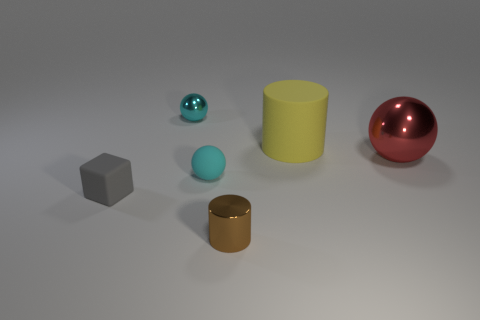Is there a brown object of the same shape as the cyan rubber object?
Offer a terse response. No. What is the shape of the other matte thing that is the same size as the gray object?
Offer a very short reply. Sphere. Is the color of the small metallic ball the same as the rubber thing to the right of the tiny brown cylinder?
Make the answer very short. No. There is a matte object on the right side of the brown shiny thing; what number of small gray blocks are behind it?
Make the answer very short. 0. There is a sphere that is left of the tiny brown cylinder and behind the cyan rubber ball; what size is it?
Make the answer very short. Small. Are there any rubber things that have the same size as the rubber block?
Offer a very short reply. Yes. Are there more yellow rubber cylinders that are right of the red ball than metal things in front of the gray rubber block?
Offer a terse response. No. Are the yellow thing and the object in front of the matte cube made of the same material?
Offer a terse response. No. How many big metallic things are on the right side of the cyan ball in front of the cylinder that is right of the tiny metallic cylinder?
Ensure brevity in your answer.  1. Do the yellow matte object and the small shiny object in front of the gray cube have the same shape?
Give a very brief answer. Yes. 